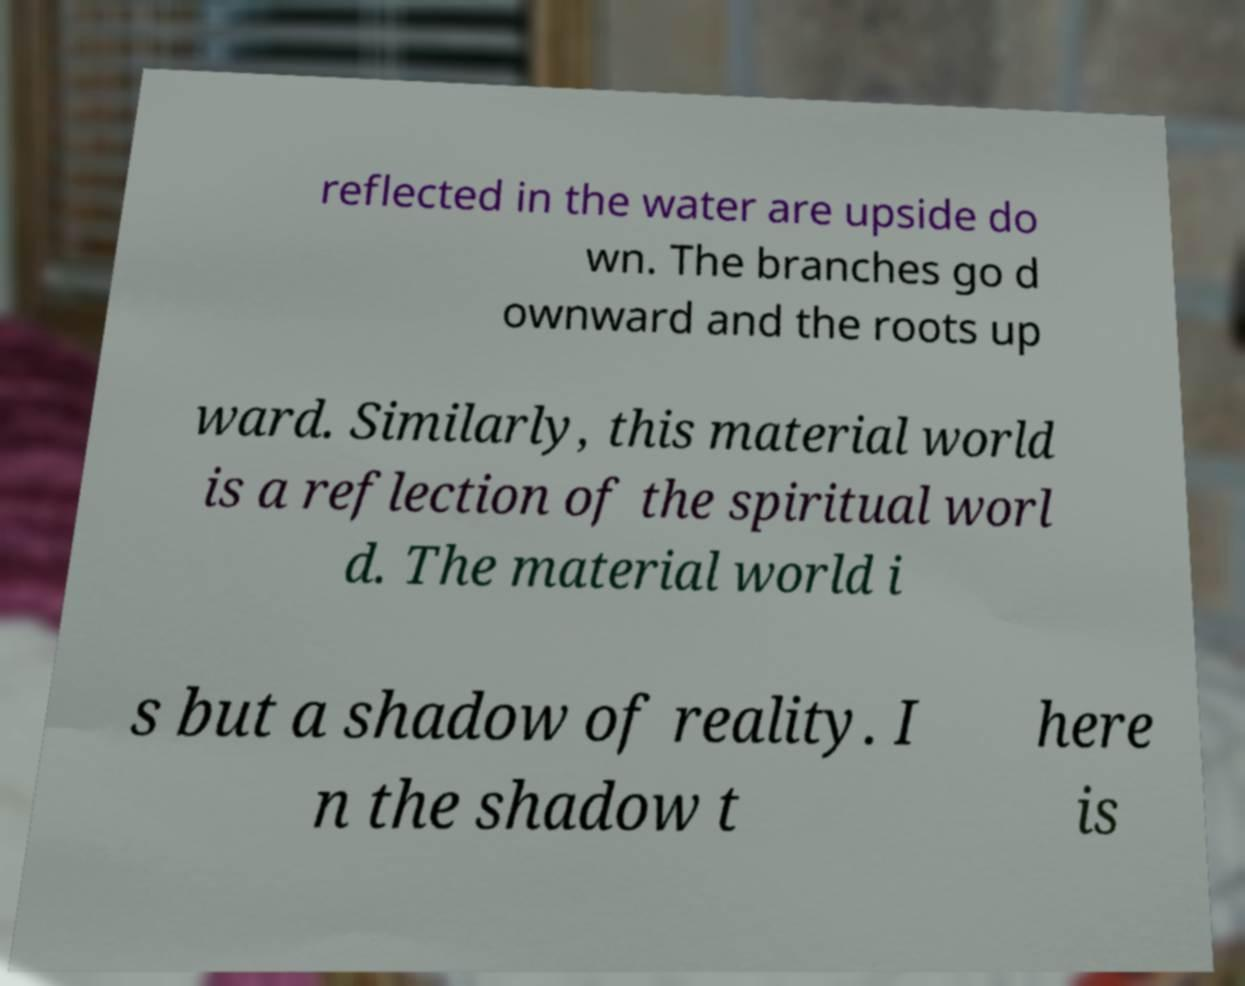There's text embedded in this image that I need extracted. Can you transcribe it verbatim? reflected in the water are upside do wn. The branches go d ownward and the roots up ward. Similarly, this material world is a reflection of the spiritual worl d. The material world i s but a shadow of reality. I n the shadow t here is 